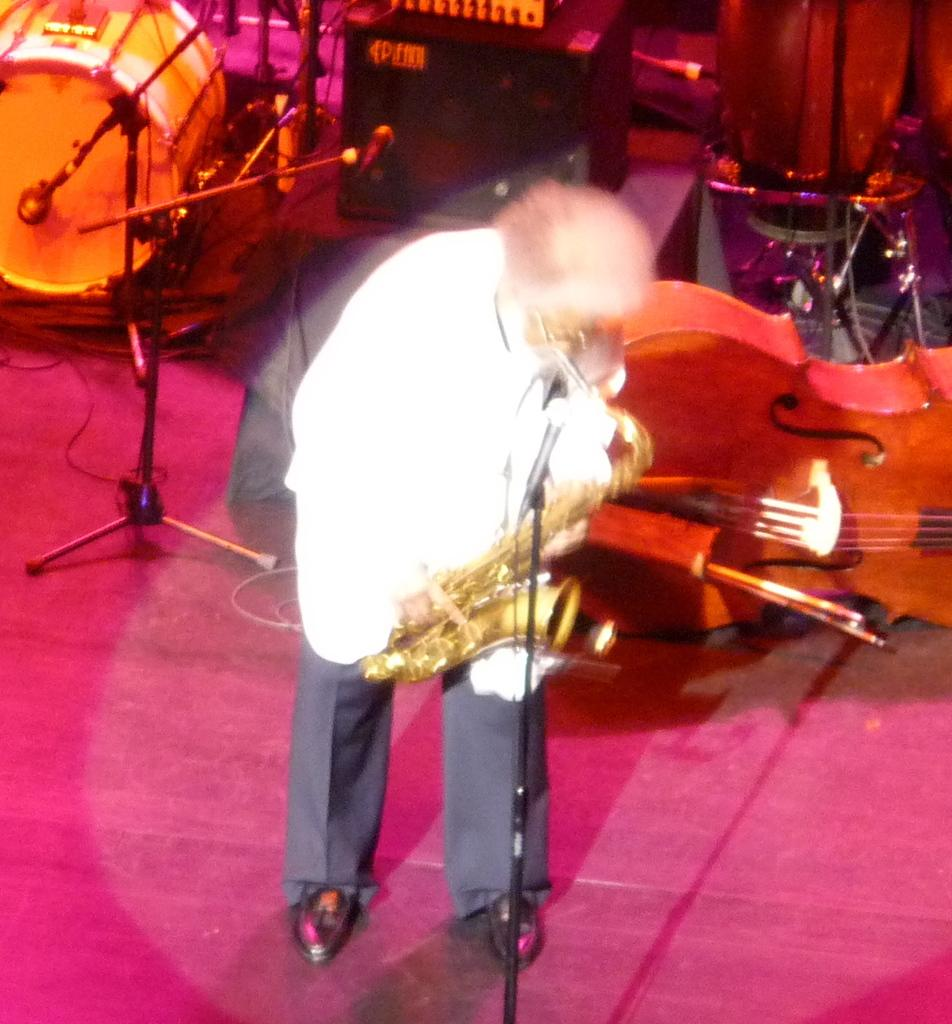What is the man doing on the stage in the image? The man is playing a sousaphone on the stage. What is the man positioned in front of on the stage? The man is in front of a microphone. What other musical instruments can be seen behind the man on the stage? There are multiple musical instruments visible behind the man on the stage. How many kittens are playing with the sousaphone in the image? There are no kittens present in the image; it features a man playing a sousaphone on a stage. What is the cause of the sousaphone's sound in the image? The cause of the sousaphone's sound in the image is the man playing it. 